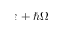Convert formula to latex. <formula><loc_0><loc_0><loc_500><loc_500>\varepsilon + \hbar { \Omega }</formula> 